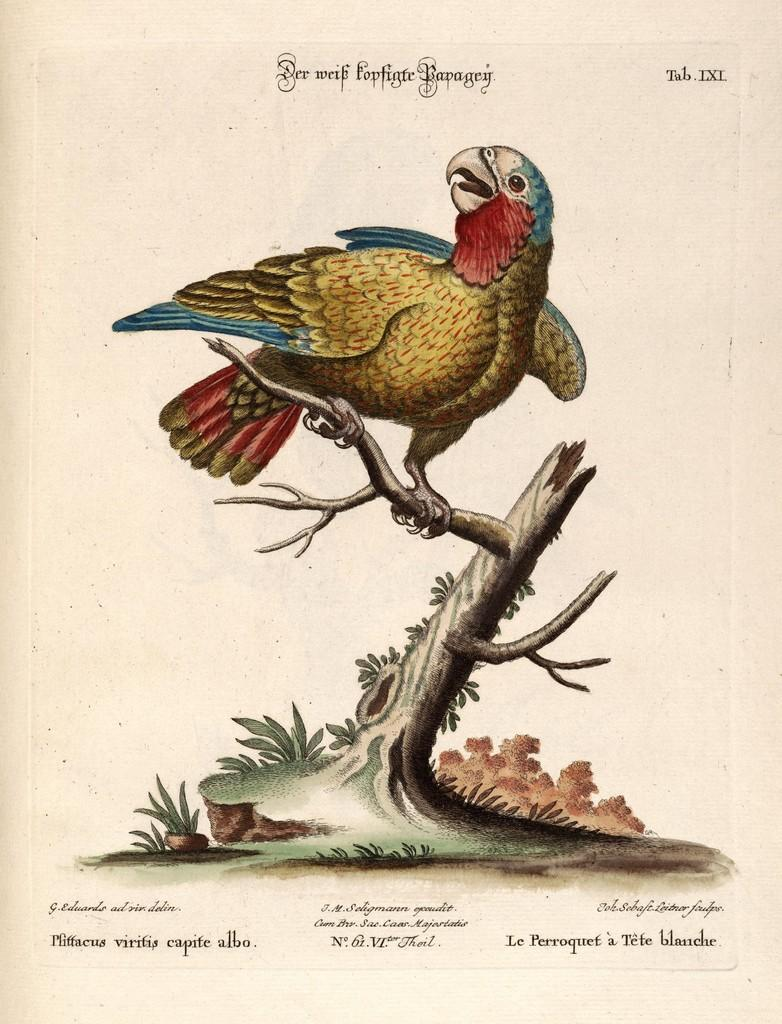What is depicted in the painting in the image? There is a painting of an eagle in the image. Where is the painting located? The painting is on a plant. What type of text can be seen in the image? There is text at the bottom and top of the image. What is the eagle's belief about the middle of the day in the image? The image is a painting of an eagle, and eagles do not have beliefs. Additionally, the image does not depict a specific time of day. 